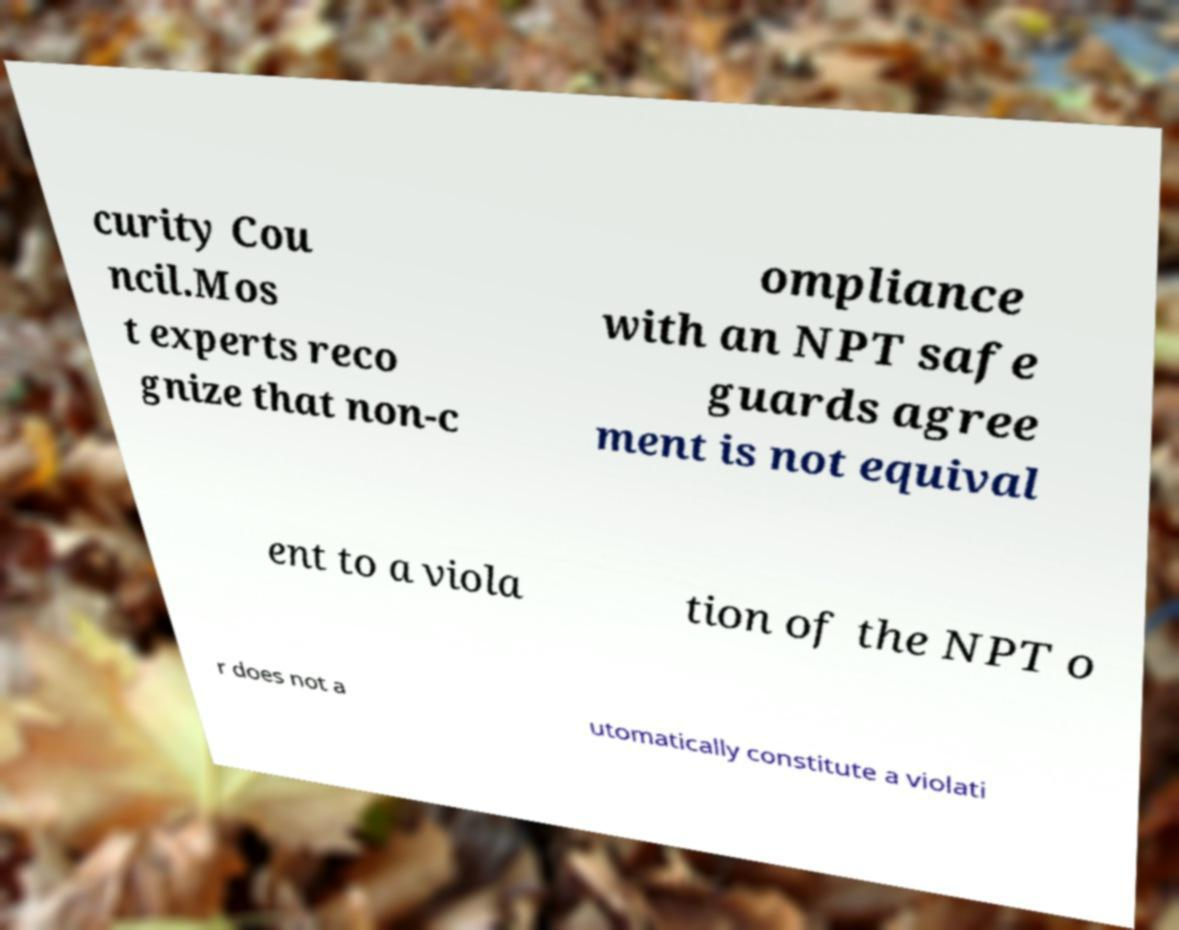Could you assist in decoding the text presented in this image and type it out clearly? curity Cou ncil.Mos t experts reco gnize that non-c ompliance with an NPT safe guards agree ment is not equival ent to a viola tion of the NPT o r does not a utomatically constitute a violati 